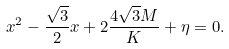Convert formula to latex. <formula><loc_0><loc_0><loc_500><loc_500>x ^ { 2 } - \frac { \sqrt { 3 } } { 2 } x + 2 \frac { 4 \sqrt { 3 } M } { K } + \eta = 0 .</formula> 